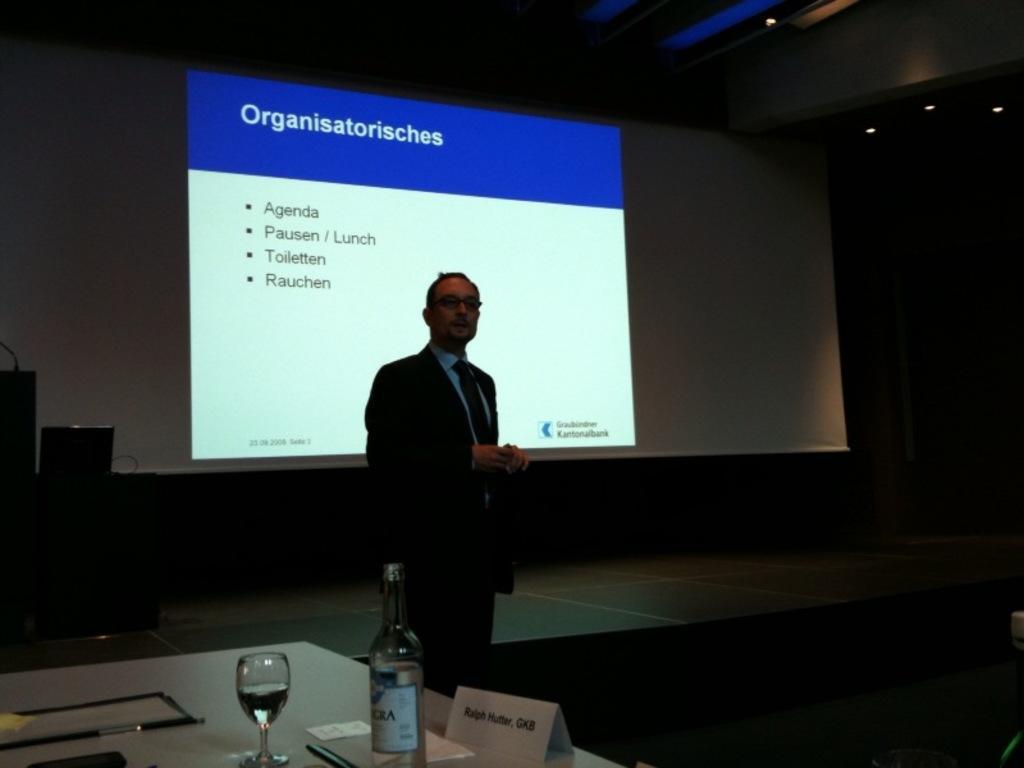Can you describe this image briefly? In this image In the middle there is a man he wears suit, tie and shirt. On the left there is a table on that there is a glass and bottle. In the background there is a screen and lights. 